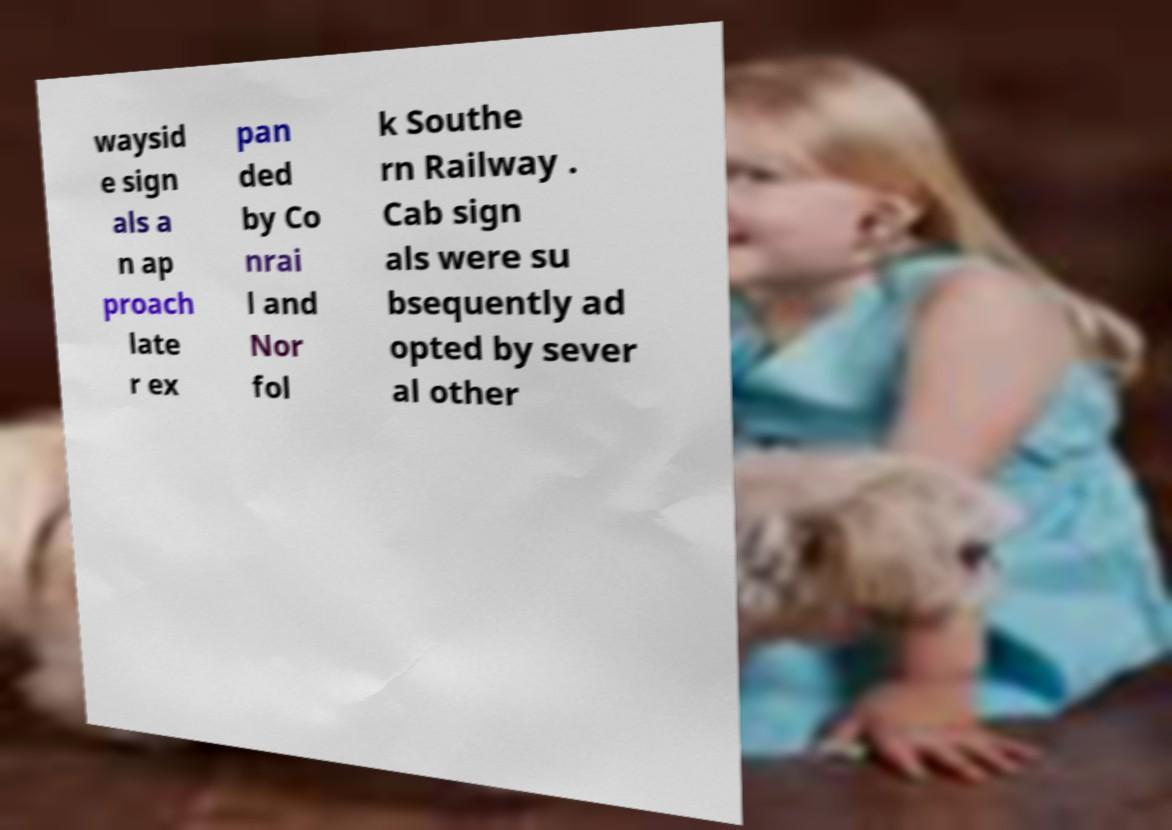Can you accurately transcribe the text from the provided image for me? waysid e sign als a n ap proach late r ex pan ded by Co nrai l and Nor fol k Southe rn Railway . Cab sign als were su bsequently ad opted by sever al other 